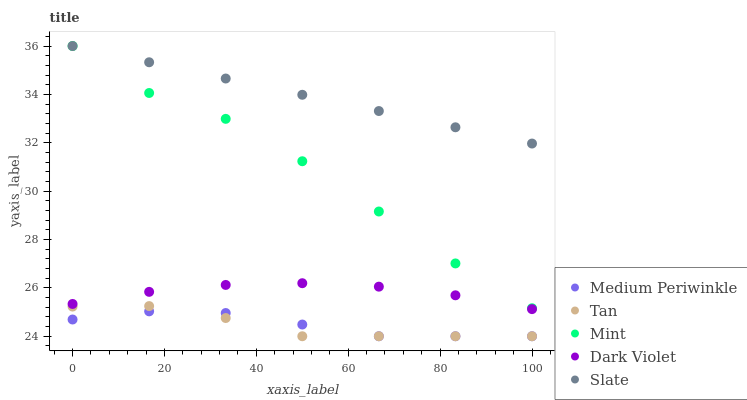Does Tan have the minimum area under the curve?
Answer yes or no. Yes. Does Slate have the maximum area under the curve?
Answer yes or no. Yes. Does Medium Periwinkle have the minimum area under the curve?
Answer yes or no. No. Does Medium Periwinkle have the maximum area under the curve?
Answer yes or no. No. Is Slate the smoothest?
Answer yes or no. Yes. Is Mint the roughest?
Answer yes or no. Yes. Is Tan the smoothest?
Answer yes or no. No. Is Tan the roughest?
Answer yes or no. No. Does Tan have the lowest value?
Answer yes or no. Yes. Does Slate have the lowest value?
Answer yes or no. No. Does Slate have the highest value?
Answer yes or no. Yes. Does Tan have the highest value?
Answer yes or no. No. Is Dark Violet less than Mint?
Answer yes or no. Yes. Is Slate greater than Medium Periwinkle?
Answer yes or no. Yes. Does Tan intersect Medium Periwinkle?
Answer yes or no. Yes. Is Tan less than Medium Periwinkle?
Answer yes or no. No. Is Tan greater than Medium Periwinkle?
Answer yes or no. No. Does Dark Violet intersect Mint?
Answer yes or no. No. 